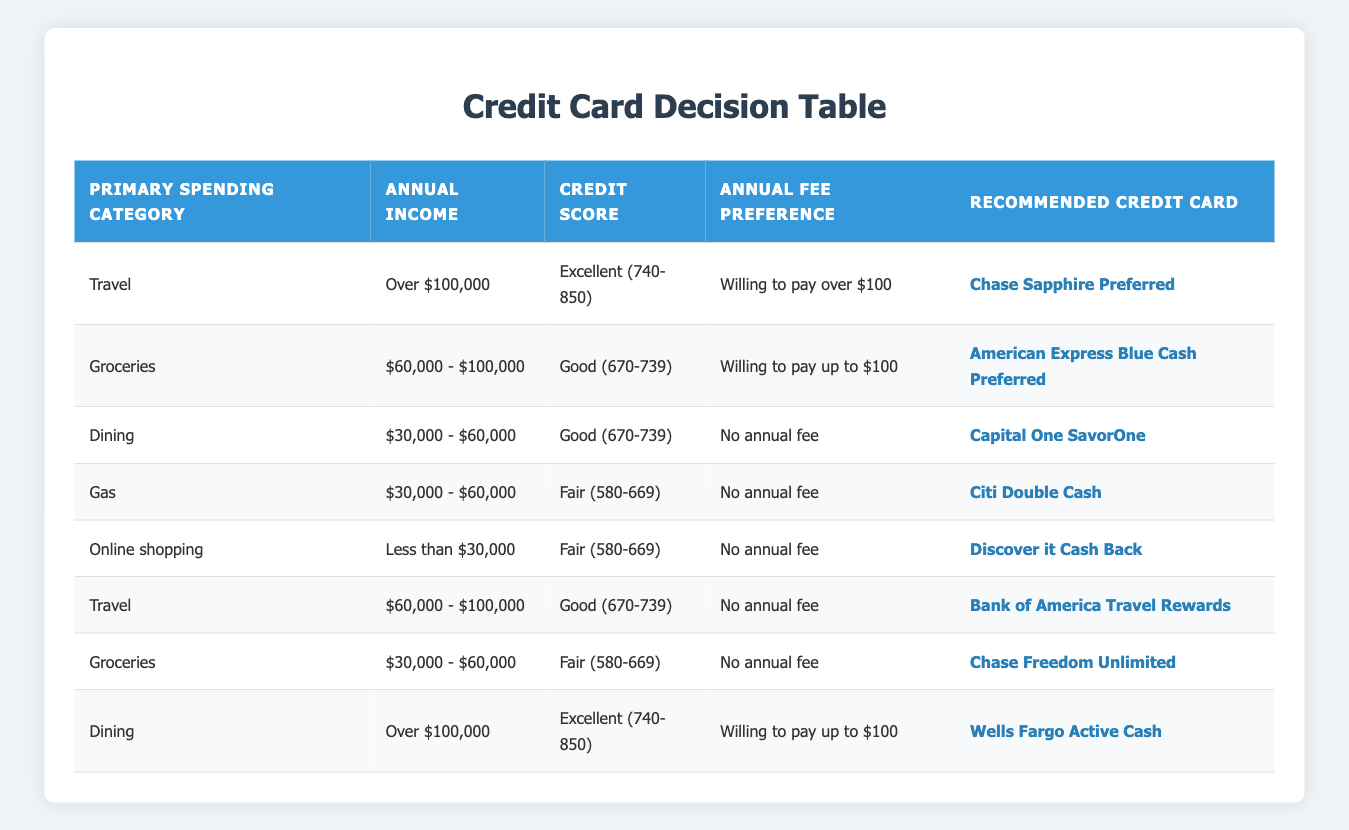What is the recommended credit card for someone who primarily spends on travel and has an excellent credit score? According to the table, the recommended credit card for someone who spends on travel (condition 1) with an excellent credit score (condition 3) is Chase Sapphire Preferred.
Answer: Chase Sapphire Preferred Which credit card should someone consider if their annual income is less than $30,000 and they prefer no annual fee? The table indicates that for an annual income of less than $30,000 (condition 2) and a preference for no annual fee (condition 4), the recommended credit card is Discover it Cash Back.
Answer: Discover it Cash Back Is Chase Freedom Unlimited recommended for anyone with a fair credit score? Yes, according to the table, Chase Freedom Unlimited is recommended for someone with a fair credit score (condition 3) who also has an annual income between $30,000 - $60,000 (condition 2) and prefers no annual fee (condition 4).
Answer: Yes Which credit card is recommended for someone with an excellent credit score and a willingness to pay up to $100 annual fee? The table reveals that the recommended credit card for someone with an excellent credit score (condition 3) and willing to pay up to $100 (condition 4) and who spends on dining (condition 1) is Wells Fargo Active Cash.
Answer: Wells Fargo Active Cash 